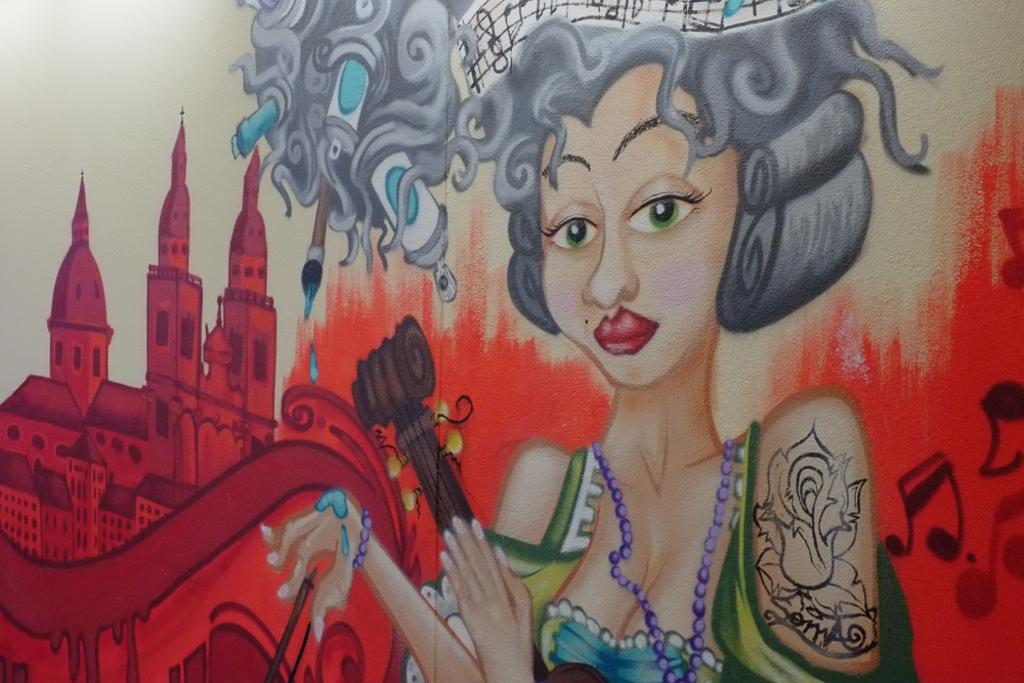What is the main subject of the image? The main subject of the image is a painting. What types of images are depicted in the painting? The painting contains images of persons and buildings. How does the wind affect the lumber in the image? There is no wind or lumber present in the image; it features a painting with images of persons and buildings. What type of pot is shown in the image? There is no pot present in the image; it features a painting with images of persons and buildings. 